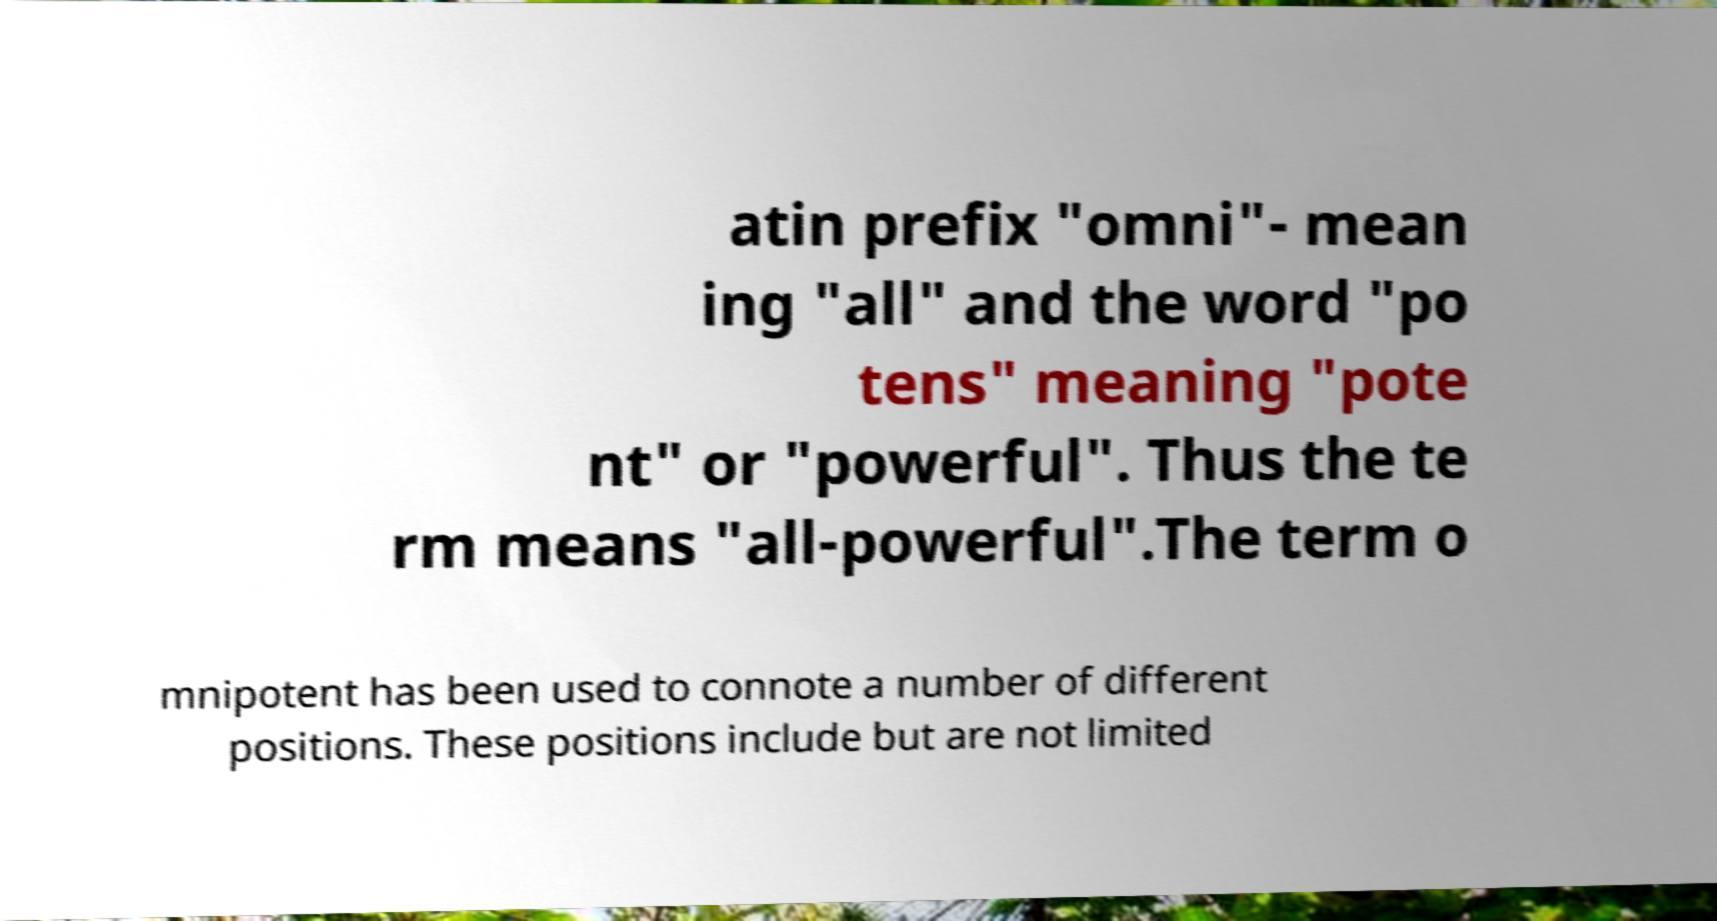I need the written content from this picture converted into text. Can you do that? atin prefix "omni"- mean ing "all" and the word "po tens" meaning "pote nt" or "powerful". Thus the te rm means "all-powerful".The term o mnipotent has been used to connote a number of different positions. These positions include but are not limited 